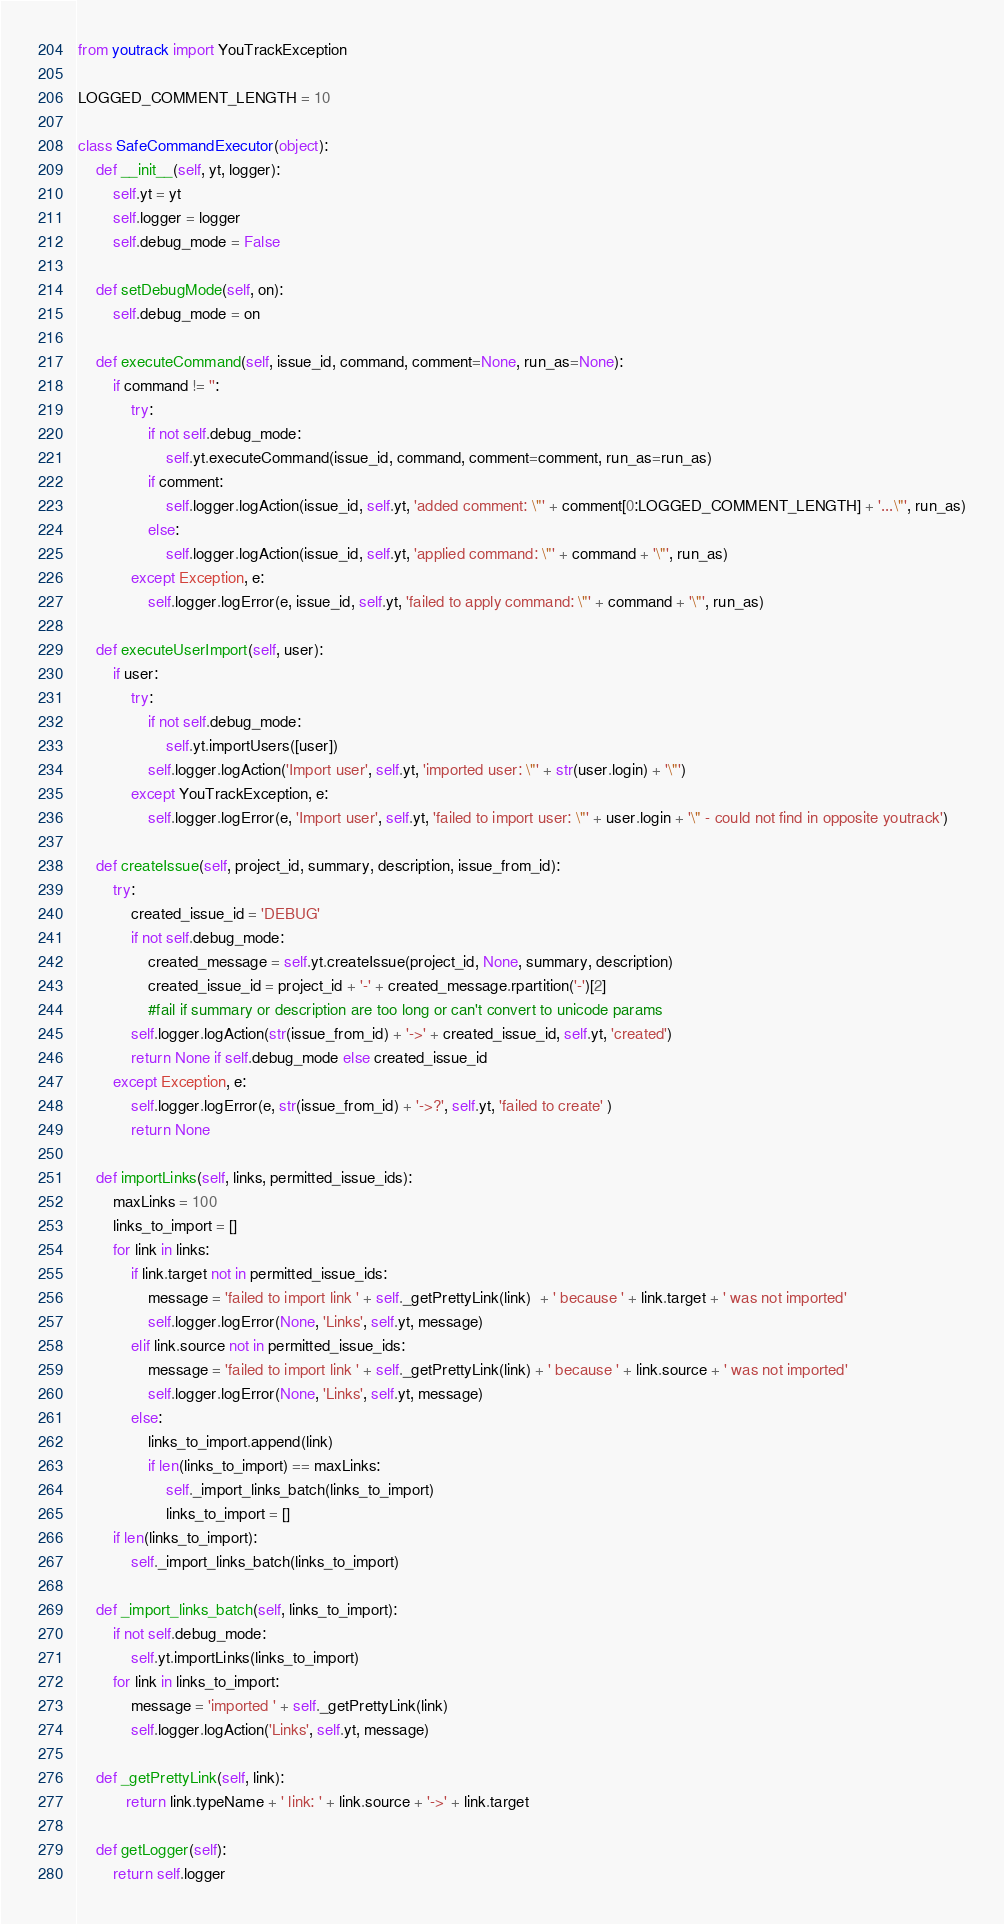Convert code to text. <code><loc_0><loc_0><loc_500><loc_500><_Python_>from youtrack import YouTrackException

LOGGED_COMMENT_LENGTH = 10

class SafeCommandExecutor(object):
    def __init__(self, yt, logger):
        self.yt = yt
        self.logger = logger
        self.debug_mode = False

    def setDebugMode(self, on):
        self.debug_mode = on

    def executeCommand(self, issue_id, command, comment=None, run_as=None):
        if command != '':
            try:
                if not self.debug_mode:
                    self.yt.executeCommand(issue_id, command, comment=comment, run_as=run_as)
                if comment:
                    self.logger.logAction(issue_id, self.yt, 'added comment: \"' + comment[0:LOGGED_COMMENT_LENGTH] + '...\"', run_as)
                else:
                    self.logger.logAction(issue_id, self.yt, 'applied command: \"' + command + '\"', run_as)
            except Exception, e:
                self.logger.logError(e, issue_id, self.yt, 'failed to apply command: \"' + command + '\"', run_as)

    def executeUserImport(self, user):
        if user:
            try:
                if not self.debug_mode:
                    self.yt.importUsers([user])
                self.logger.logAction('Import user', self.yt, 'imported user: \"' + str(user.login) + '\"')
            except YouTrackException, e:
                self.logger.logError(e, 'Import user', self.yt, 'failed to import user: \"' + user.login + '\" - could not find in opposite youtrack')

    def createIssue(self, project_id, summary, description, issue_from_id):
        try:
            created_issue_id = 'DEBUG'
            if not self.debug_mode:
                created_message = self.yt.createIssue(project_id, None, summary, description)
                created_issue_id = project_id + '-' + created_message.rpartition('-')[2]
                #fail if summary or description are too long or can't convert to unicode params
            self.logger.logAction(str(issue_from_id) + '->' + created_issue_id, self.yt, 'created')
            return None if self.debug_mode else created_issue_id
        except Exception, e:
            self.logger.logError(e, str(issue_from_id) + '->?', self.yt, 'failed to create' )
            return None

    def importLinks(self, links, permitted_issue_ids):
        maxLinks = 100
        links_to_import = []
        for link in links:
            if link.target not in permitted_issue_ids:
                message = 'failed to import link ' + self._getPrettyLink(link)  + ' because ' + link.target + ' was not imported'
                self.logger.logError(None, 'Links', self.yt, message)
            elif link.source not in permitted_issue_ids:
                message = 'failed to import link ' + self._getPrettyLink(link) + ' because ' + link.source + ' was not imported'
                self.logger.logError(None, 'Links', self.yt, message)
            else:
                links_to_import.append(link)
                if len(links_to_import) == maxLinks:
                    self._import_links_batch(links_to_import)
                    links_to_import = []
        if len(links_to_import):
            self._import_links_batch(links_to_import)

    def _import_links_batch(self, links_to_import):
        if not self.debug_mode:
            self.yt.importLinks(links_to_import)
        for link in links_to_import:
            message = 'imported ' + self._getPrettyLink(link)
            self.logger.logAction('Links', self.yt, message)

    def _getPrettyLink(self, link):
           return link.typeName + ' link: ' + link.source + '->' + link.target

    def getLogger(self):
        return self.logger</code> 